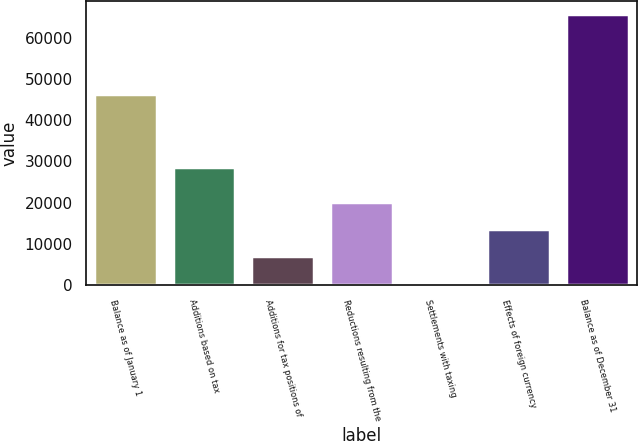<chart> <loc_0><loc_0><loc_500><loc_500><bar_chart><fcel>Balance as of January 1<fcel>Additions based on tax<fcel>Additions for tax positions of<fcel>Reductions resulting from the<fcel>Settlements with taxing<fcel>Effects of foreign currency<fcel>Balance as of December 31<nl><fcel>46434<fcel>28663<fcel>7152.6<fcel>20147.8<fcel>655<fcel>13650.2<fcel>65631<nl></chart> 